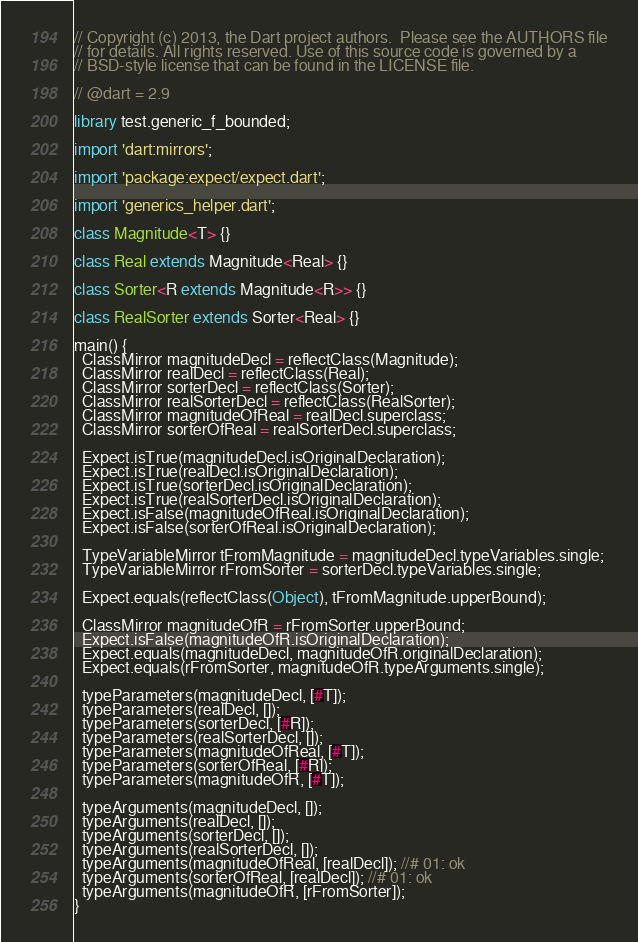<code> <loc_0><loc_0><loc_500><loc_500><_Dart_>// Copyright (c) 2013, the Dart project authors.  Please see the AUTHORS file
// for details. All rights reserved. Use of this source code is governed by a
// BSD-style license that can be found in the LICENSE file.

// @dart = 2.9

library test.generic_f_bounded;

import 'dart:mirrors';

import 'package:expect/expect.dart';

import 'generics_helper.dart';

class Magnitude<T> {}

class Real extends Magnitude<Real> {}

class Sorter<R extends Magnitude<R>> {}

class RealSorter extends Sorter<Real> {}

main() {
  ClassMirror magnitudeDecl = reflectClass(Magnitude);
  ClassMirror realDecl = reflectClass(Real);
  ClassMirror sorterDecl = reflectClass(Sorter);
  ClassMirror realSorterDecl = reflectClass(RealSorter);
  ClassMirror magnitudeOfReal = realDecl.superclass;
  ClassMirror sorterOfReal = realSorterDecl.superclass;

  Expect.isTrue(magnitudeDecl.isOriginalDeclaration);
  Expect.isTrue(realDecl.isOriginalDeclaration);
  Expect.isTrue(sorterDecl.isOriginalDeclaration);
  Expect.isTrue(realSorterDecl.isOriginalDeclaration);
  Expect.isFalse(magnitudeOfReal.isOriginalDeclaration);
  Expect.isFalse(sorterOfReal.isOriginalDeclaration);

  TypeVariableMirror tFromMagnitude = magnitudeDecl.typeVariables.single;
  TypeVariableMirror rFromSorter = sorterDecl.typeVariables.single;

  Expect.equals(reflectClass(Object), tFromMagnitude.upperBound);

  ClassMirror magnitudeOfR = rFromSorter.upperBound;
  Expect.isFalse(magnitudeOfR.isOriginalDeclaration);
  Expect.equals(magnitudeDecl, magnitudeOfR.originalDeclaration);
  Expect.equals(rFromSorter, magnitudeOfR.typeArguments.single);

  typeParameters(magnitudeDecl, [#T]);
  typeParameters(realDecl, []);
  typeParameters(sorterDecl, [#R]);
  typeParameters(realSorterDecl, []);
  typeParameters(magnitudeOfReal, [#T]);
  typeParameters(sorterOfReal, [#R]);
  typeParameters(magnitudeOfR, [#T]);

  typeArguments(magnitudeDecl, []);
  typeArguments(realDecl, []);
  typeArguments(sorterDecl, []);
  typeArguments(realSorterDecl, []);
  typeArguments(magnitudeOfReal, [realDecl]); //# 01: ok
  typeArguments(sorterOfReal, [realDecl]); //# 01: ok
  typeArguments(magnitudeOfR, [rFromSorter]);
}
</code> 